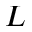<formula> <loc_0><loc_0><loc_500><loc_500>L</formula> 